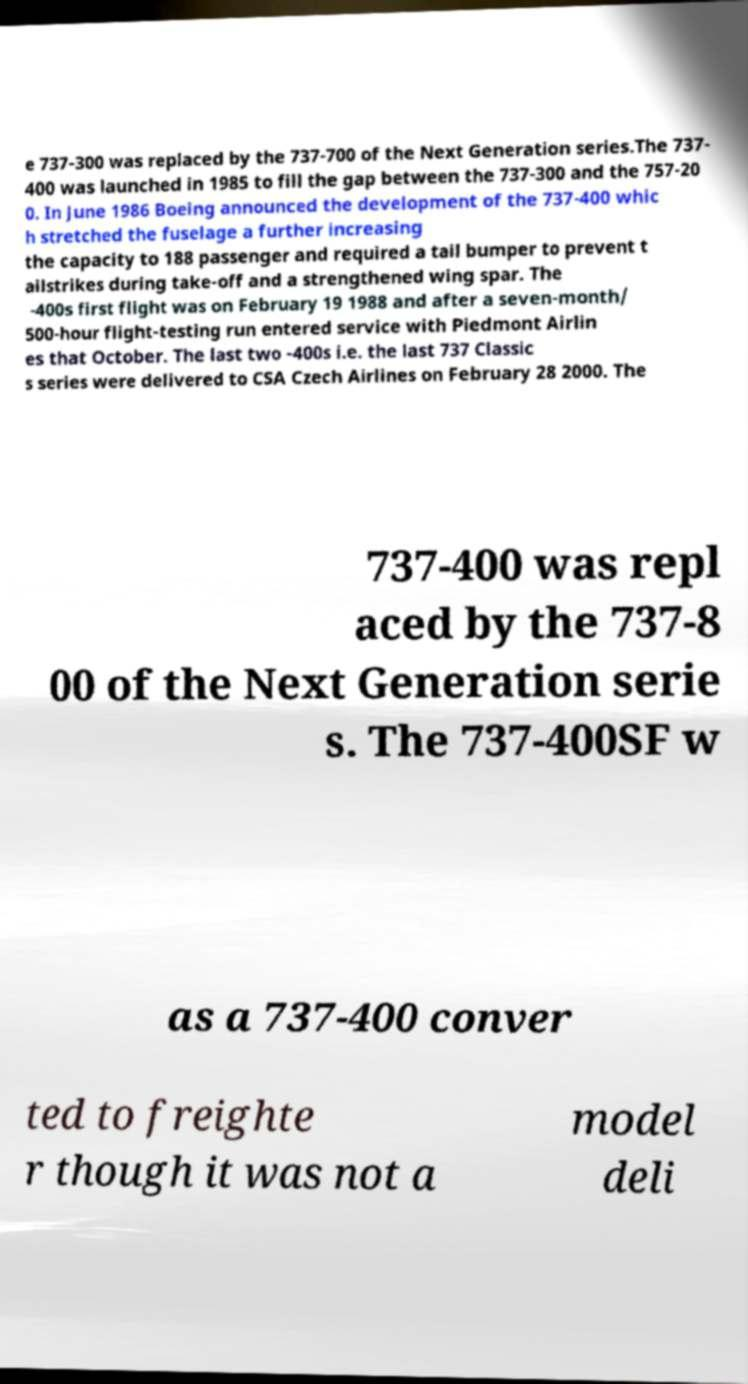Can you read and provide the text displayed in the image?This photo seems to have some interesting text. Can you extract and type it out for me? e 737-300 was replaced by the 737-700 of the Next Generation series.The 737- 400 was launched in 1985 to fill the gap between the 737-300 and the 757-20 0. In June 1986 Boeing announced the development of the 737-400 whic h stretched the fuselage a further increasing the capacity to 188 passenger and required a tail bumper to prevent t ailstrikes during take-off and a strengthened wing spar. The -400s first flight was on February 19 1988 and after a seven-month/ 500-hour flight-testing run entered service with Piedmont Airlin es that October. The last two -400s i.e. the last 737 Classic s series were delivered to CSA Czech Airlines on February 28 2000. The 737-400 was repl aced by the 737-8 00 of the Next Generation serie s. The 737-400SF w as a 737-400 conver ted to freighte r though it was not a model deli 